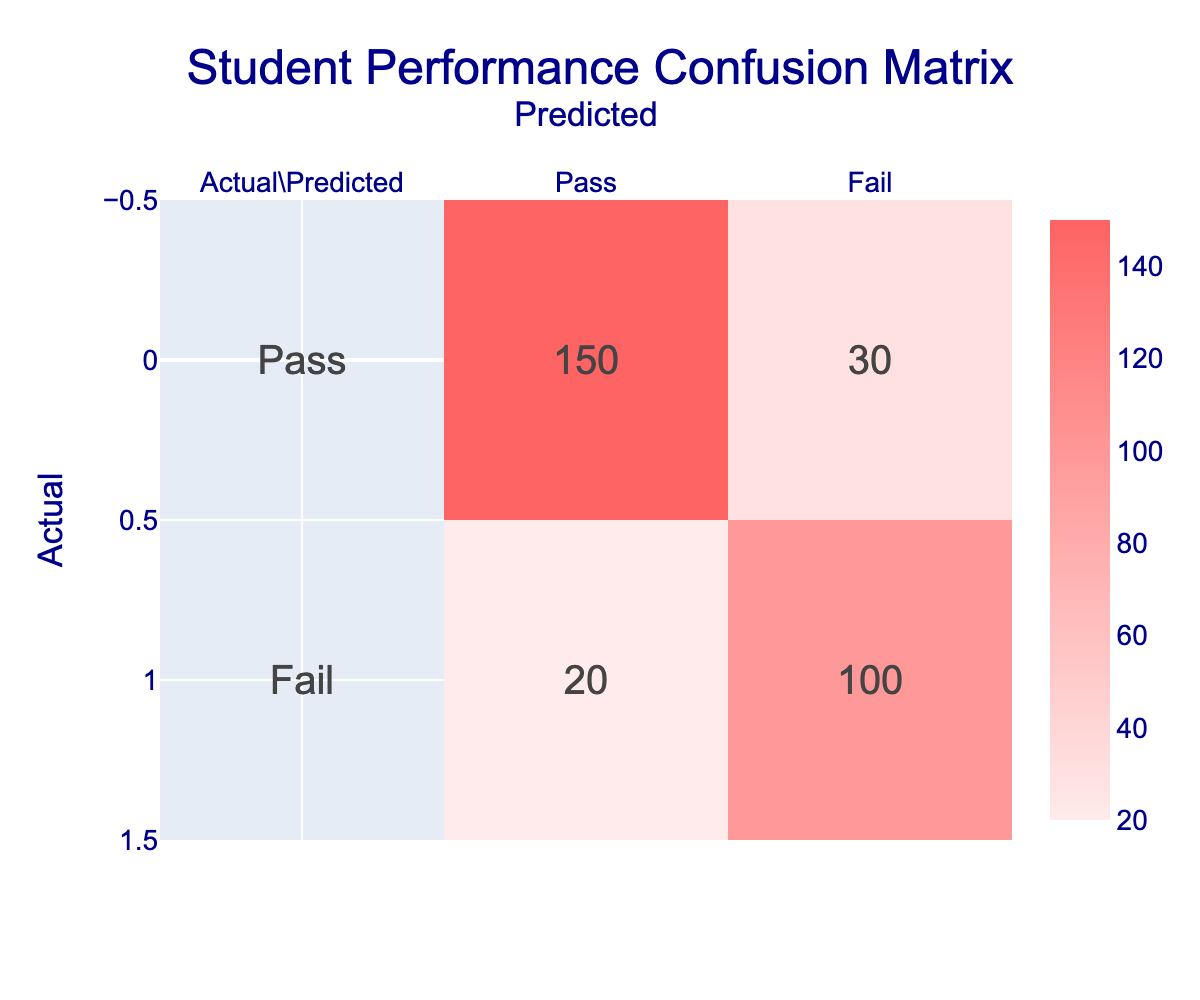What is the total number of students predicted to pass the standardized test? To find the total number of students predicted to pass, we look at the "Pass" column. According to the table, 150 students were predicted to pass.
Answer: 150 What is the total number of students predicted to fail the standardized test? To determine this, we refer to the "Fail" column. The table indicates that 30 students were predicted to fail.
Answer: 30 How many students actually passed the standardized test? The "Actual" row for "Pass" shows that 150 students passed the test.
Answer: 150 What is the total number of students who actually failed the standardized test? We refer to the "Actual" row for "Fail," which shows that 100 students failed the test.
Answer: 100 Is it true that more students were predicted to pass than actually passed? The predicted number of students passing is 150, while the actual number is also 150, so this statement is false.
Answer: No What is the ratio of students who predicted to pass versus those who actually passed? The predicted number of students who passed is 150, and the actual number is also 150. The ratio is therefore 150:150, which simplifies to 1:1.
Answer: 1:1 What is the difference between the number of students who actually failed and those who were predicted to fail? The number of students who actually failed is 100, while those predicted to fail is 20. The difference is 100 - 20 = 80.
Answer: 80 What percentage of students who passed were predicted to fail? The actual number of students who passed is 150. The predicted number who failed is 30. So the percentage calculated as (30 / 150) * 100 = 20%.
Answer: 20% If we combine the numbers of predicted passes and fails, what is the total number of predictions made? To find the total predictions, add the numbers in the predicted column: predicted passes (150) + predicted fails (30). This equals 180.
Answer: 180 If we compare the actual results versus the predictions, how many total predictions were incorrect? We need to look at the actual numbers and the predictions. The predicted "Fail" was 20, but the actual "Fail" is 100. Hence, the incorrect predictions are the sum of the false predictions, which is 20 (predicted Pass) + 30 (actual Fail) = 50 incorrect predictions.
Answer: 50 